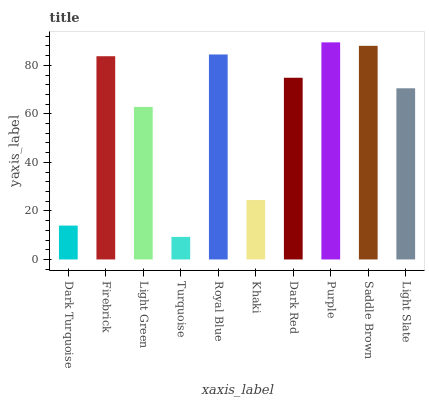Is Firebrick the minimum?
Answer yes or no. No. Is Firebrick the maximum?
Answer yes or no. No. Is Firebrick greater than Dark Turquoise?
Answer yes or no. Yes. Is Dark Turquoise less than Firebrick?
Answer yes or no. Yes. Is Dark Turquoise greater than Firebrick?
Answer yes or no. No. Is Firebrick less than Dark Turquoise?
Answer yes or no. No. Is Dark Red the high median?
Answer yes or no. Yes. Is Light Slate the low median?
Answer yes or no. Yes. Is Dark Turquoise the high median?
Answer yes or no. No. Is Dark Turquoise the low median?
Answer yes or no. No. 